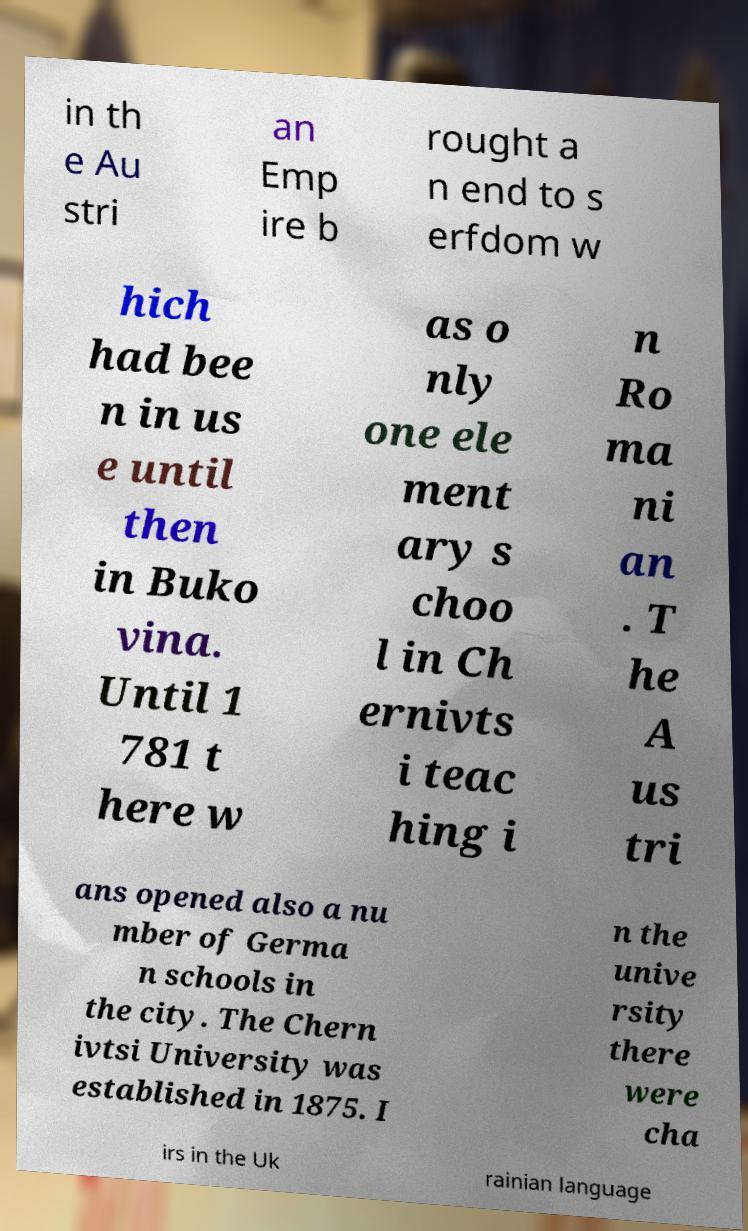What messages or text are displayed in this image? I need them in a readable, typed format. in th e Au stri an Emp ire b rought a n end to s erfdom w hich had bee n in us e until then in Buko vina. Until 1 781 t here w as o nly one ele ment ary s choo l in Ch ernivts i teac hing i n Ro ma ni an . T he A us tri ans opened also a nu mber of Germa n schools in the city. The Chern ivtsi University was established in 1875. I n the unive rsity there were cha irs in the Uk rainian language 